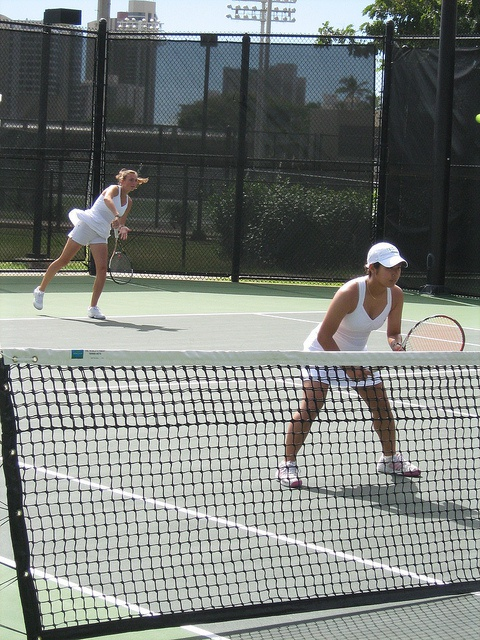Describe the objects in this image and their specific colors. I can see people in lavender, darkgray, lightgray, gray, and maroon tones, people in lavender, darkgray, gray, and lightgray tones, tennis racket in lavender, lightgray, darkgray, and tan tones, and tennis racket in lavender, gray, black, and darkgray tones in this image. 